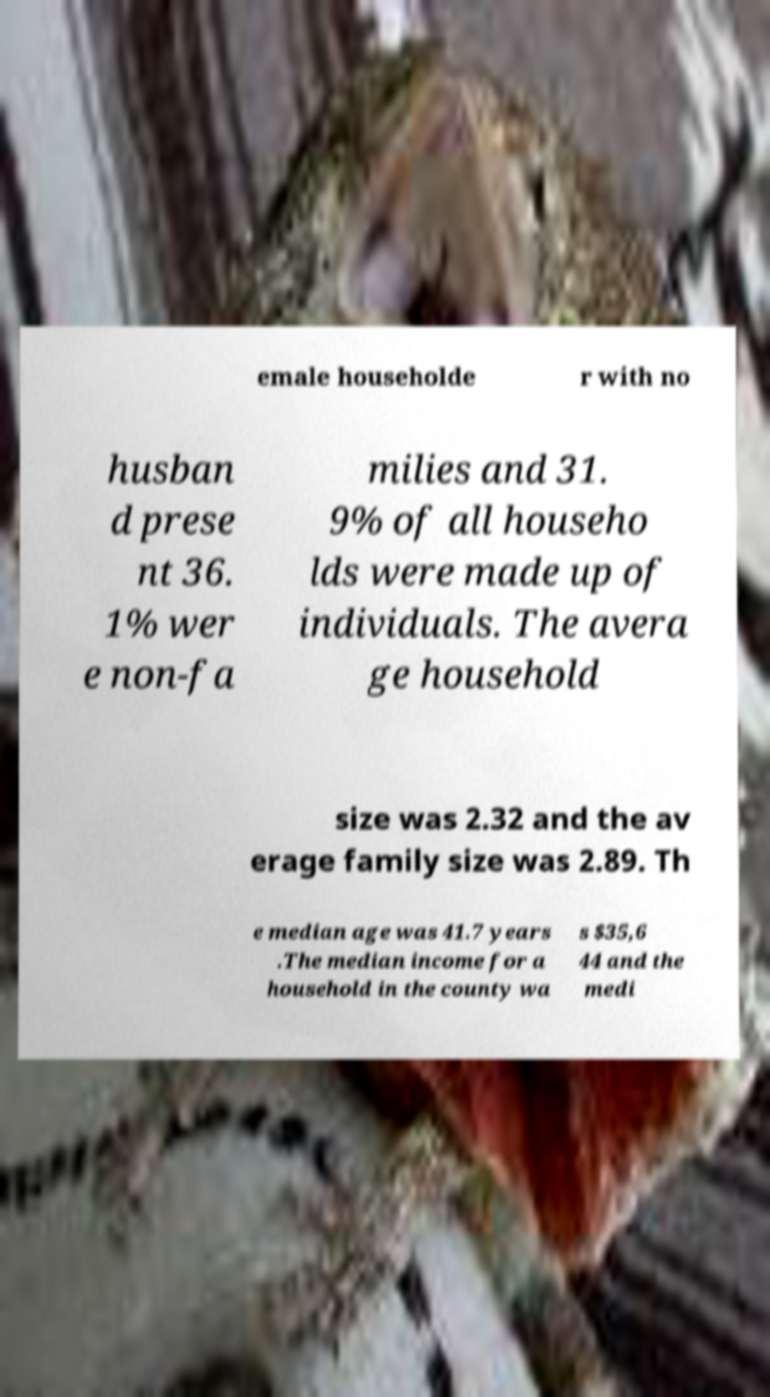There's text embedded in this image that I need extracted. Can you transcribe it verbatim? emale householde r with no husban d prese nt 36. 1% wer e non-fa milies and 31. 9% of all househo lds were made up of individuals. The avera ge household size was 2.32 and the av erage family size was 2.89. Th e median age was 41.7 years .The median income for a household in the county wa s $35,6 44 and the medi 